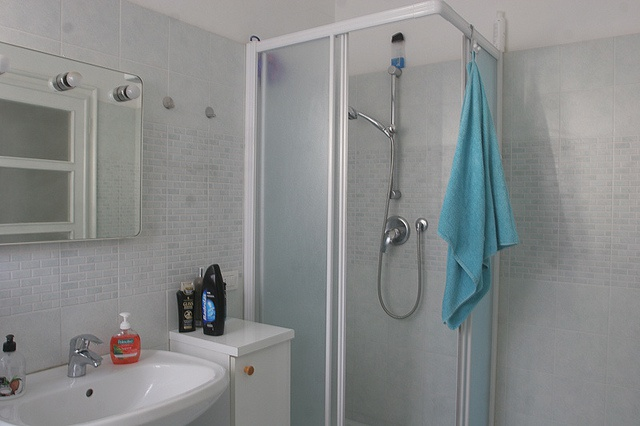Describe the objects in this image and their specific colors. I can see sink in darkgray, gray, and lightgray tones, bottle in darkgray, gray, and black tones, bottle in darkgray, black, blue, gray, and navy tones, bottle in darkgray, brown, and gray tones, and bottle in darkgray, black, and gray tones in this image. 